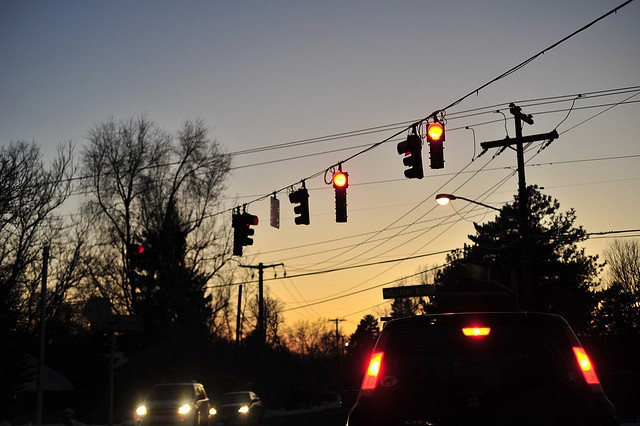Describe the objects in this image and their specific colors. I can see car in darkblue, black, maroon, yellow, and red tones, car in darkblue, black, gray, and tan tones, car in darkblue, black, gray, and ivory tones, traffic light in darkblue, black, gray, and darkgray tones, and traffic light in darkblue, black, yellow, maroon, and red tones in this image. 